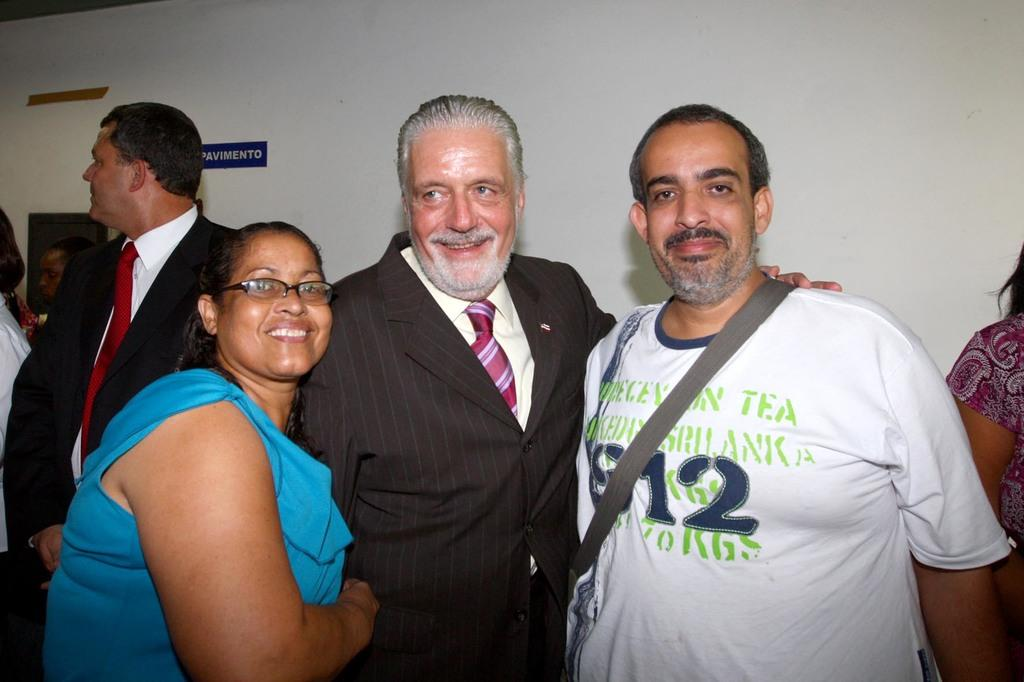How many people are present in the image? There are a few people in the image. What can be seen in the background of the image? There is a wall with some objects in the background. What is written or displayed on the board in the image? There is a board with some text in the image. What type of coat is hanging on the wall in the image? There is no coat present in the image; only a wall with some objects is visible in the background. 